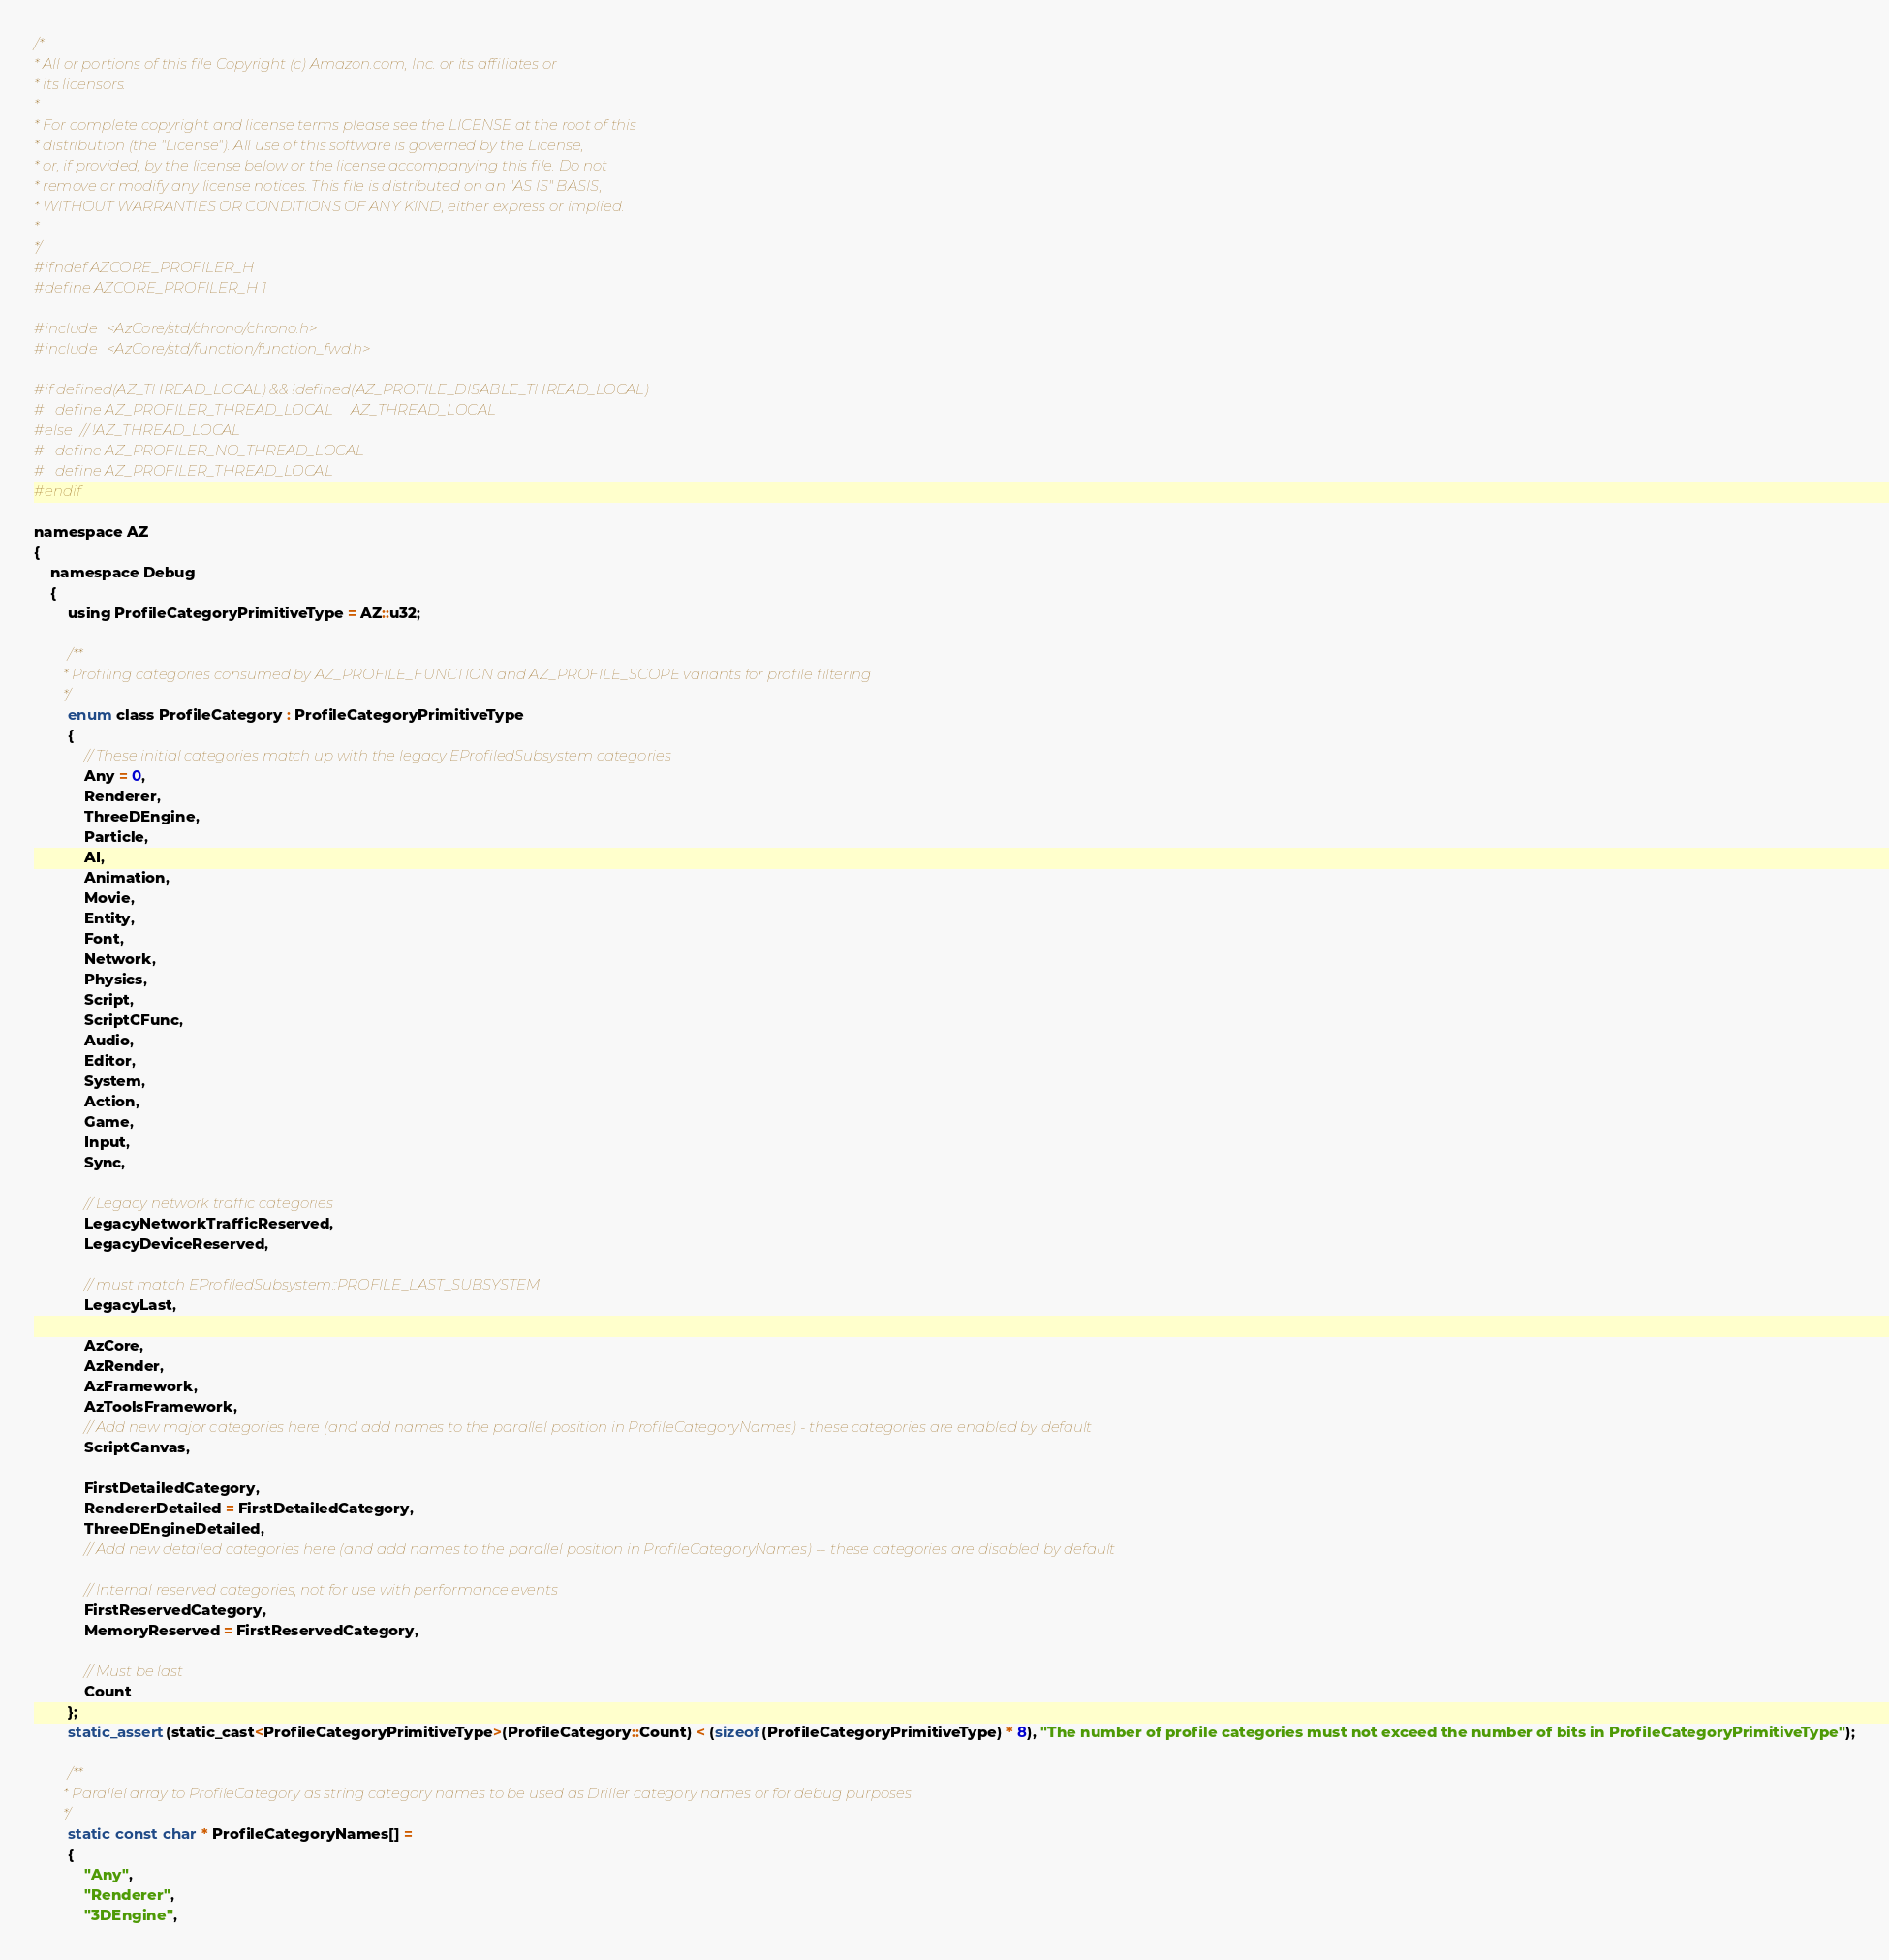<code> <loc_0><loc_0><loc_500><loc_500><_C_>/*
* All or portions of this file Copyright (c) Amazon.com, Inc. or its affiliates or
* its licensors.
*
* For complete copyright and license terms please see the LICENSE at the root of this
* distribution (the "License"). All use of this software is governed by the License,
* or, if provided, by the license below or the license accompanying this file. Do not
* remove or modify any license notices. This file is distributed on an "AS IS" BASIS,
* WITHOUT WARRANTIES OR CONDITIONS OF ANY KIND, either express or implied.
*
*/
#ifndef AZCORE_PROFILER_H
#define AZCORE_PROFILER_H 1

#include <AzCore/std/chrono/chrono.h>
#include <AzCore/std/function/function_fwd.h>

#if defined(AZ_THREAD_LOCAL) && !defined(AZ_PROFILE_DISABLE_THREAD_LOCAL)
#   define AZ_PROFILER_THREAD_LOCAL     AZ_THREAD_LOCAL
#else // !AZ_THREAD_LOCAL
#   define AZ_PROFILER_NO_THREAD_LOCAL
#   define AZ_PROFILER_THREAD_LOCAL
#endif

namespace AZ
{
    namespace Debug
    {
        using ProfileCategoryPrimitiveType = AZ::u32;

        /**
        * Profiling categories consumed by AZ_PROFILE_FUNCTION and AZ_PROFILE_SCOPE variants for profile filtering
        */
        enum class ProfileCategory : ProfileCategoryPrimitiveType
        {
            // These initial categories match up with the legacy EProfiledSubsystem categories
            Any = 0,
            Renderer,
            ThreeDEngine,
            Particle,
            AI,
            Animation,
            Movie,
            Entity,
            Font,
            Network,
            Physics,
            Script,
            ScriptCFunc,
            Audio,
            Editor,
            System,
            Action,
            Game,
            Input,
            Sync,

            // Legacy network traffic categories
            LegacyNetworkTrafficReserved,
            LegacyDeviceReserved,

            // must match EProfiledSubsystem::PROFILE_LAST_SUBSYSTEM
            LegacyLast,

            AzCore,
            AzRender,
            AzFramework,
            AzToolsFramework,
            // Add new major categories here (and add names to the parallel position in ProfileCategoryNames) - these categories are enabled by default
            ScriptCanvas,

            FirstDetailedCategory,
            RendererDetailed = FirstDetailedCategory,
            ThreeDEngineDetailed,
            // Add new detailed categories here (and add names to the parallel position in ProfileCategoryNames) -- these categories are disabled by default
            
            // Internal reserved categories, not for use with performance events
            FirstReservedCategory,
            MemoryReserved = FirstReservedCategory,

            // Must be last
            Count
        };
        static_assert(static_cast<ProfileCategoryPrimitiveType>(ProfileCategory::Count) < (sizeof(ProfileCategoryPrimitiveType) * 8), "The number of profile categories must not exceed the number of bits in ProfileCategoryPrimitiveType");

        /**
        * Parallel array to ProfileCategory as string category names to be used as Driller category names or for debug purposes
        */
        static const char * ProfileCategoryNames[] =
        {
            "Any",
            "Renderer",
            "3DEngine",</code> 